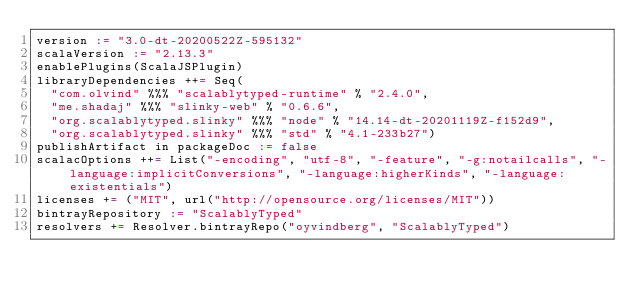<code> <loc_0><loc_0><loc_500><loc_500><_Scala_>version := "3.0-dt-20200522Z-595132"
scalaVersion := "2.13.3"
enablePlugins(ScalaJSPlugin)
libraryDependencies ++= Seq(
  "com.olvind" %%% "scalablytyped-runtime" % "2.4.0",
  "me.shadaj" %%% "slinky-web" % "0.6.6",
  "org.scalablytyped.slinky" %%% "node" % "14.14-dt-20201119Z-f152d9",
  "org.scalablytyped.slinky" %%% "std" % "4.1-233b27")
publishArtifact in packageDoc := false
scalacOptions ++= List("-encoding", "utf-8", "-feature", "-g:notailcalls", "-language:implicitConversions", "-language:higherKinds", "-language:existentials")
licenses += ("MIT", url("http://opensource.org/licenses/MIT"))
bintrayRepository := "ScalablyTyped"
resolvers += Resolver.bintrayRepo("oyvindberg", "ScalablyTyped")
</code> 